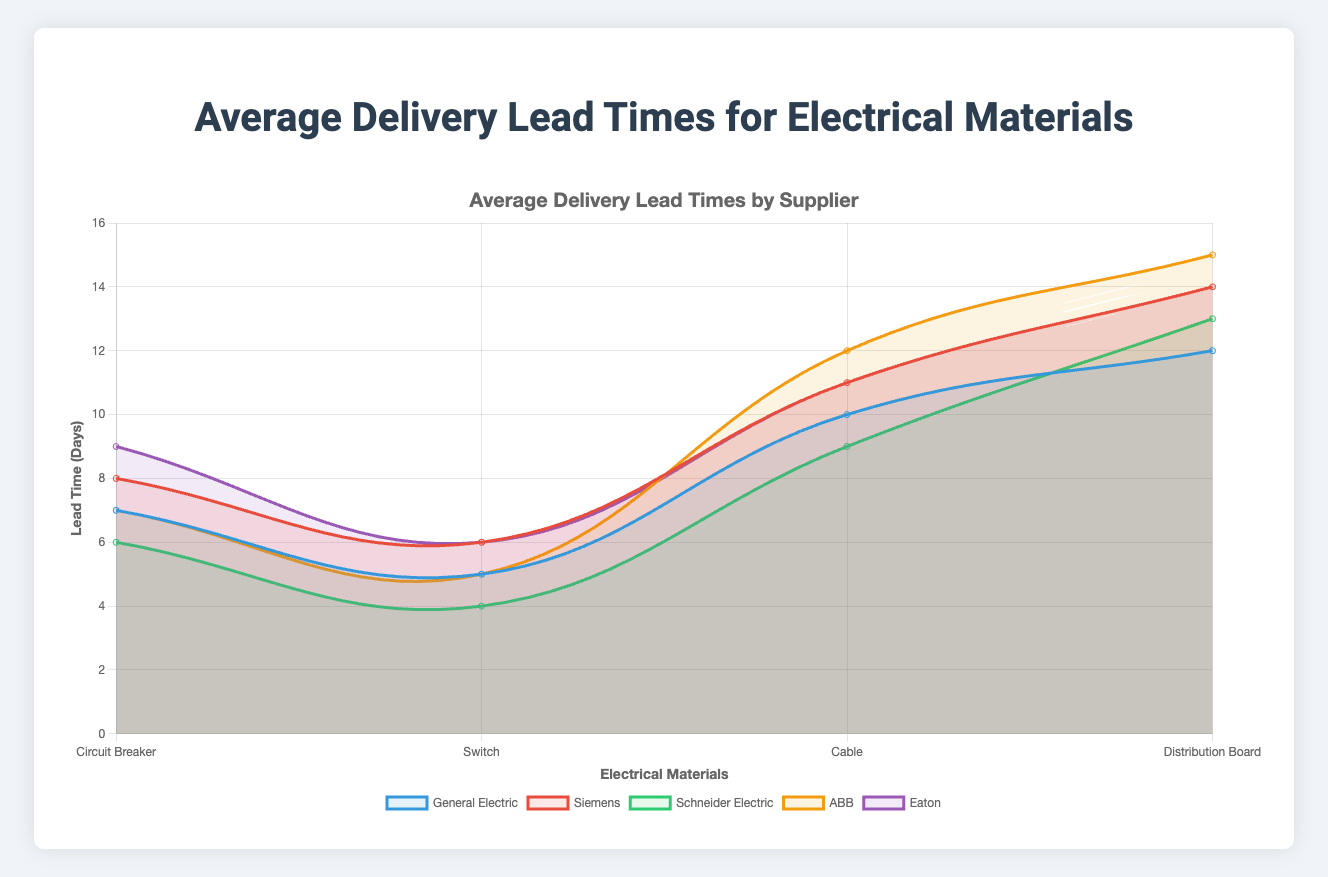What is the average lead time for Circuit Breakers across all suppliers? Sum the lead times for Circuit Breakers for each supplier: General Electric (7 days), Siemens (8 days), Schneider Electric (6 days), ABB (7 days), Eaton (9 days). The total is 7+8+6+7+9 = 37. Divide this by the number of suppliers: 37 / 5 = 7.4 days.
Answer: 7.4 days Which supplier has the shortest average lead time for Switches? Compare the lead times for Switches: General Electric (5 days), Siemens (6 days), Schneider Electric (4 days), ABB (5 days), Eaton (6 days). Schneider Electric has the shortest lead time of 4 days.
Answer: Schneider Electric Which material has the longest average delivery lead time overall? Compare the average delivery lead times across all materials for each supplier: Circuit Breaker (6 - 9 days), Switch (4 - 6 days), Cable (9 - 12 days), Distribution Board (12 - 15 days). Distribution Boards have the longest average lead times, ranging from 12 to 15 days.
Answer: Distribution Board What is the difference in lead times for Cables between ABB and Schneider Electric? ABB's lead time for Cables is 12 days, Schneider Electric's lead time is 9 days. The difference is 12 - 9 = 3 days.
Answer: 3 days Which supplier offers the most consistent lead times across all materials? Consistency can be interpreted as the smallest difference between the shortest and longest lead times. Calculate the range for each supplier: General Electric (12-5=7), Siemens (14-6=8), Schneider Electric (13-4=9), ABB (15-5=10), Eaton (14-6=8). General Electric has the smallest range of 7 days, making it the most consistent.
Answer: General Electric By how many days is the lead time for Distribution Boards from Eaton longer than that from General Electric? Eaton's lead time for Distribution Boards is 14 days, General Electric's lead time is 12 days. The difference is 14 - 12 = 2 days.
Answer: 2 days Order the suppliers based on their average lead time for Switches from shortest to longest. List the lead times for Switches: Schneider Electric (4 days), General Electric (5 days), ABB (5 days), Siemens (6 days), Eaton (6 days). The order from shortest to longest is: Schneider Electric, General Electric / ABB, Siemens / Eaton.
Answer: Schneider Electric, General Electric / ABB, Siemens / Eaton What is the combined lead time for Circuit Breakers from General Electric and Siemens? General Electric's lead time for Circuit Breakers is 7 days, Siemens' is 8 days. The combined lead time is 7 + 8 = 15 days.
Answer: 15 days Which supplier has the highest lead time for any material? Look for the highest lead time in the dataset for any material: ABB has a lead time of 15 days for Distribution Boards, which is the highest among all suppliers and materials.
Answer: ABB 